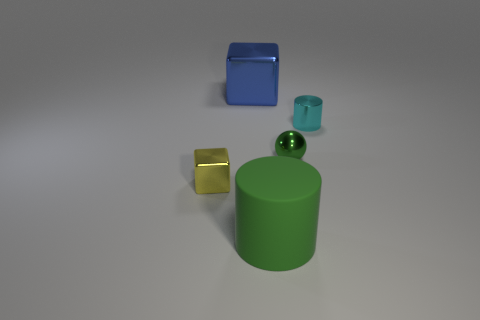The large object behind the cube in front of the metallic cylinder is made of what material?
Offer a terse response. Metal. Is the size of the blue thing the same as the cylinder in front of the cyan cylinder?
Your response must be concise. Yes. Are there any large matte things of the same color as the metallic sphere?
Provide a short and direct response. Yes. How many small objects are metal cubes or green rubber cylinders?
Ensure brevity in your answer.  1. What number of gray metal things are there?
Your answer should be compact. 0. There is a block behind the cyan metallic cylinder; what is it made of?
Provide a succinct answer. Metal. There is a green ball; are there any big objects in front of it?
Provide a short and direct response. Yes. Is the size of the cyan metallic object the same as the green shiny thing?
Provide a short and direct response. Yes. How many big cylinders are made of the same material as the big blue thing?
Offer a very short reply. 0. There is a cylinder in front of the cylinder that is right of the large green rubber cylinder; what is its size?
Your answer should be compact. Large. 